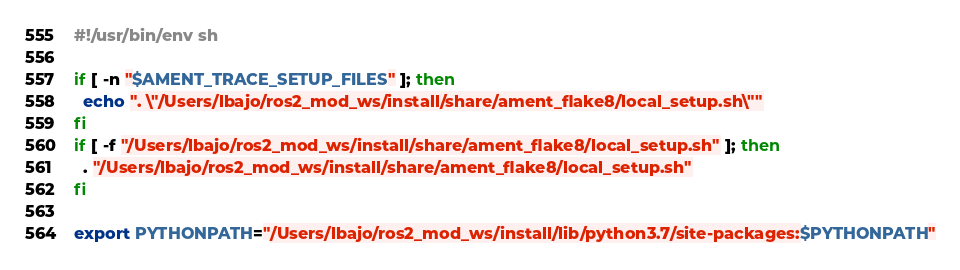<code> <loc_0><loc_0><loc_500><loc_500><_Bash_>#!/usr/bin/env sh

if [ -n "$AMENT_TRACE_SETUP_FILES" ]; then
  echo ". \"/Users/lbajo/ros2_mod_ws/install/share/ament_flake8/local_setup.sh\""
fi
if [ -f "/Users/lbajo/ros2_mod_ws/install/share/ament_flake8/local_setup.sh" ]; then
  . "/Users/lbajo/ros2_mod_ws/install/share/ament_flake8/local_setup.sh"
fi

export PYTHONPATH="/Users/lbajo/ros2_mod_ws/install/lib/python3.7/site-packages:$PYTHONPATH"
</code> 